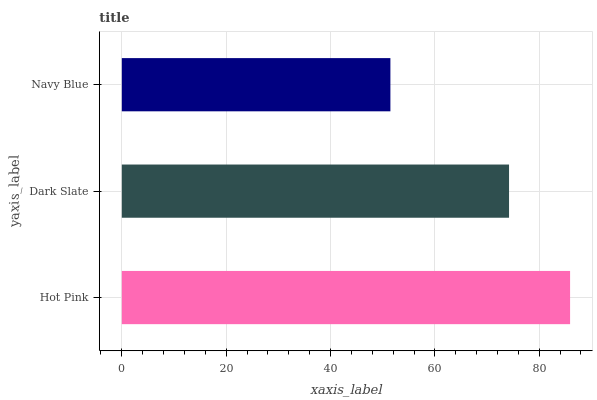Is Navy Blue the minimum?
Answer yes or no. Yes. Is Hot Pink the maximum?
Answer yes or no. Yes. Is Dark Slate the minimum?
Answer yes or no. No. Is Dark Slate the maximum?
Answer yes or no. No. Is Hot Pink greater than Dark Slate?
Answer yes or no. Yes. Is Dark Slate less than Hot Pink?
Answer yes or no. Yes. Is Dark Slate greater than Hot Pink?
Answer yes or no. No. Is Hot Pink less than Dark Slate?
Answer yes or no. No. Is Dark Slate the high median?
Answer yes or no. Yes. Is Dark Slate the low median?
Answer yes or no. Yes. Is Hot Pink the high median?
Answer yes or no. No. Is Navy Blue the low median?
Answer yes or no. No. 